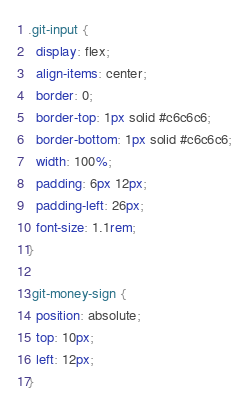<code> <loc_0><loc_0><loc_500><loc_500><_CSS_>.git-input {
  display: flex;
  align-items: center;
  border: 0;
  border-top: 1px solid #c6c6c6;
  border-bottom: 1px solid #c6c6c6;
  width: 100%;
  padding: 6px 12px;
  padding-left: 26px;
  font-size: 1.1rem;
}

.git-money-sign {
  position: absolute;
  top: 10px;
  left: 12px;
}</code> 